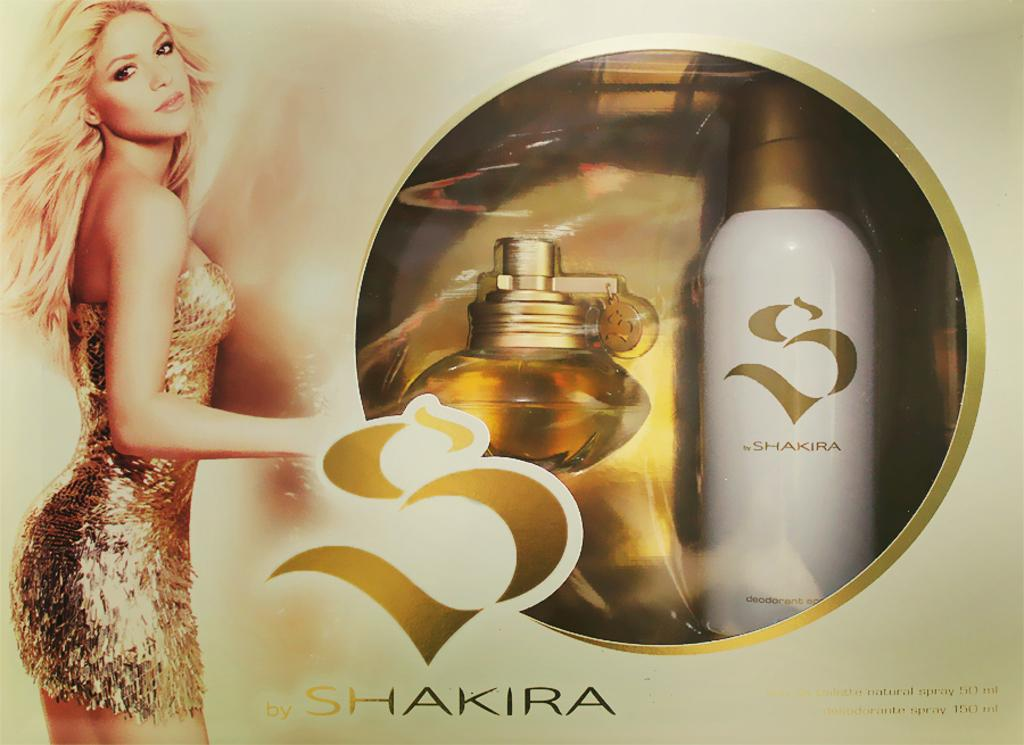<image>
Write a terse but informative summary of the picture. A woman stands next to a package of perfume called Shakira. 